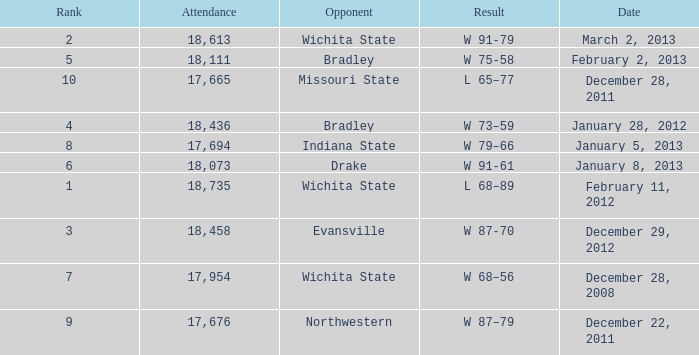What's the rank when attendance was less than 18,073 and having Northwestern as an opponent? 9.0. 